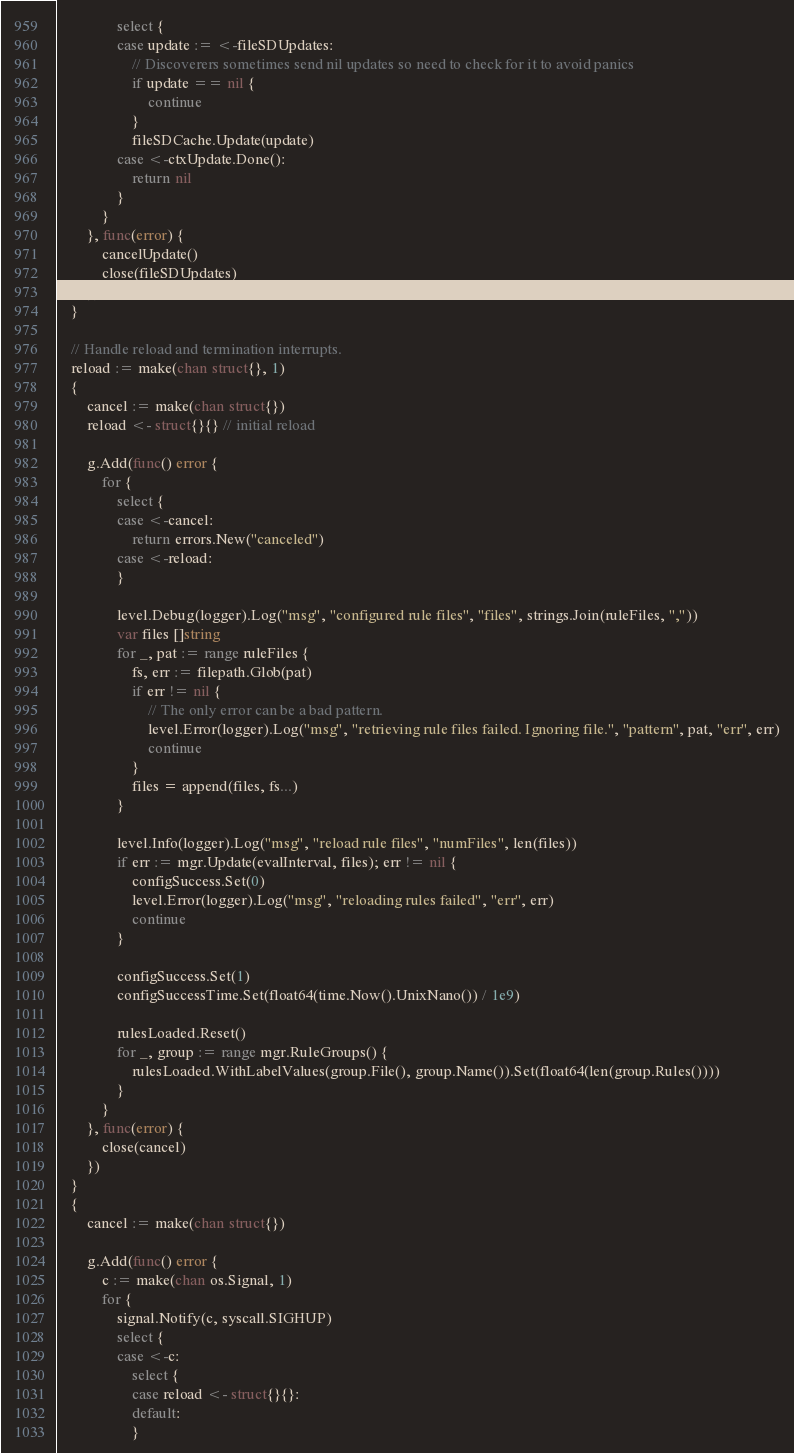Convert code to text. <code><loc_0><loc_0><loc_500><loc_500><_Go_>				select {
				case update := <-fileSDUpdates:
					// Discoverers sometimes send nil updates so need to check for it to avoid panics
					if update == nil {
						continue
					}
					fileSDCache.Update(update)
				case <-ctxUpdate.Done():
					return nil
				}
			}
		}, func(error) {
			cancelUpdate()
			close(fileSDUpdates)
		})
	}

	// Handle reload and termination interrupts.
	reload := make(chan struct{}, 1)
	{
		cancel := make(chan struct{})
		reload <- struct{}{} // initial reload

		g.Add(func() error {
			for {
				select {
				case <-cancel:
					return errors.New("canceled")
				case <-reload:
				}

				level.Debug(logger).Log("msg", "configured rule files", "files", strings.Join(ruleFiles, ","))
				var files []string
				for _, pat := range ruleFiles {
					fs, err := filepath.Glob(pat)
					if err != nil {
						// The only error can be a bad pattern.
						level.Error(logger).Log("msg", "retrieving rule files failed. Ignoring file.", "pattern", pat, "err", err)
						continue
					}
					files = append(files, fs...)
				}

				level.Info(logger).Log("msg", "reload rule files", "numFiles", len(files))
				if err := mgr.Update(evalInterval, files); err != nil {
					configSuccess.Set(0)
					level.Error(logger).Log("msg", "reloading rules failed", "err", err)
					continue
				}

				configSuccess.Set(1)
				configSuccessTime.Set(float64(time.Now().UnixNano()) / 1e9)

				rulesLoaded.Reset()
				for _, group := range mgr.RuleGroups() {
					rulesLoaded.WithLabelValues(group.File(), group.Name()).Set(float64(len(group.Rules())))
				}
			}
		}, func(error) {
			close(cancel)
		})
	}
	{
		cancel := make(chan struct{})

		g.Add(func() error {
			c := make(chan os.Signal, 1)
			for {
				signal.Notify(c, syscall.SIGHUP)
				select {
				case <-c:
					select {
					case reload <- struct{}{}:
					default:
					}</code> 